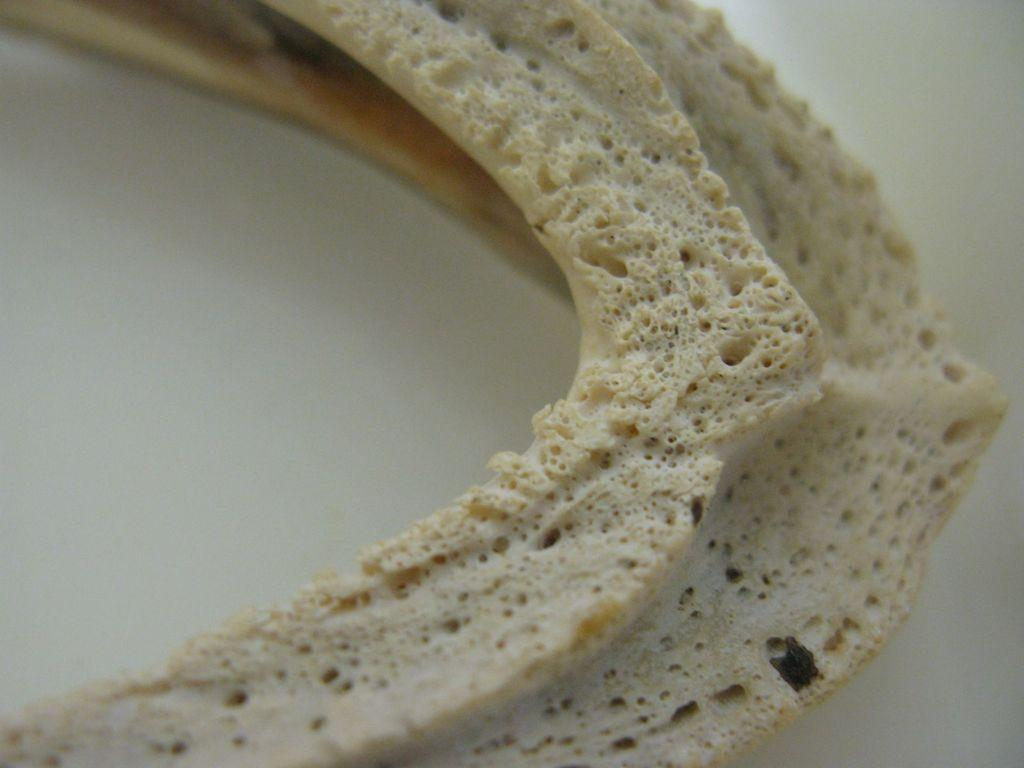What is the main subject of the image? There is a food item in the image. What color is the background of the image? The background of the image is white. Reasoning: Let's think step by identifying the main subject and the background color. We start by mentioning the food item as the main subject, which is the only fact provided about the image. Then, we describe the background color, which is white. We avoid making any assumptions about the image and only focus on the facts given. Absurd Question/Answer: How many girls are present in the image? There is no mention of girls in the image, so we cannot determine their presence or number. What note is the actor singing in the image? There is no mention of an actor or singing in the image, so we cannot determine if an actor is present or what note they might be singing. 